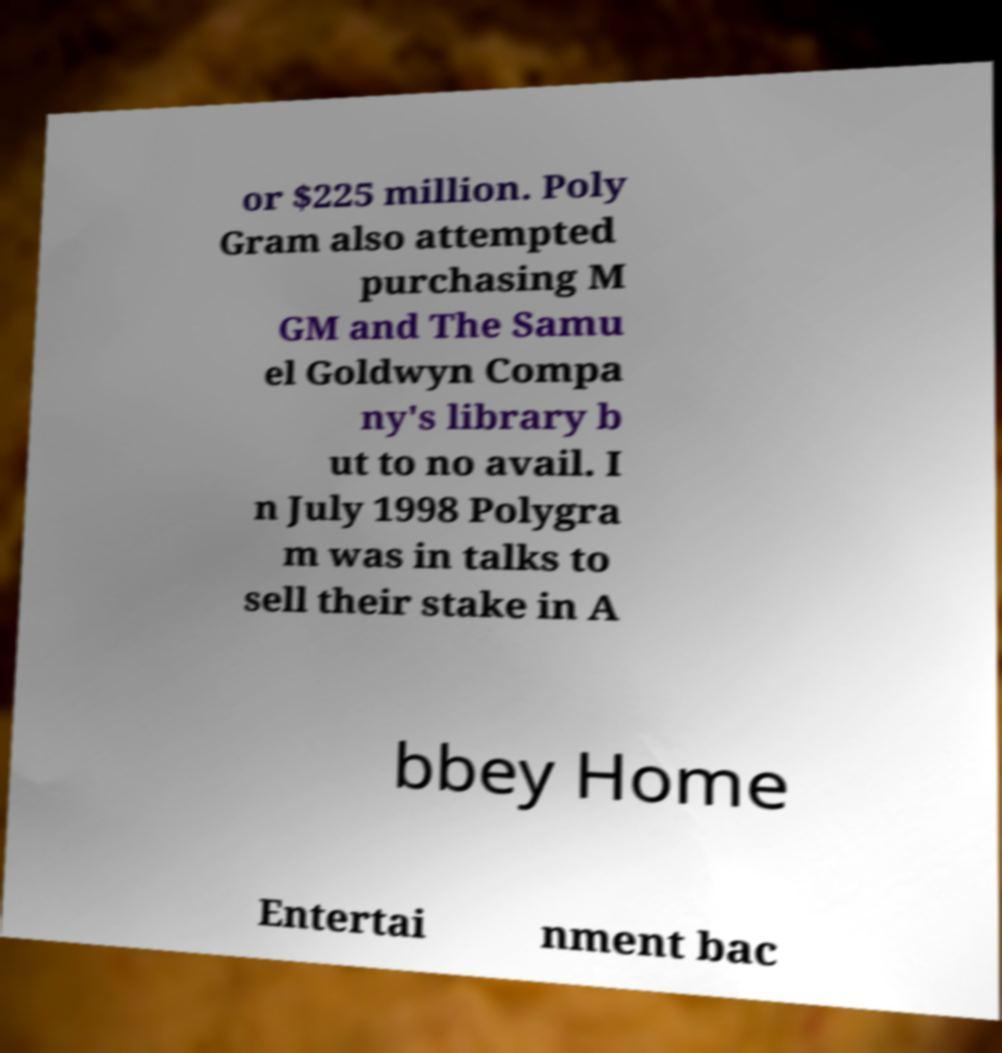I need the written content from this picture converted into text. Can you do that? or $225 million. Poly Gram also attempted purchasing M GM and The Samu el Goldwyn Compa ny's library b ut to no avail. I n July 1998 Polygra m was in talks to sell their stake in A bbey Home Entertai nment bac 